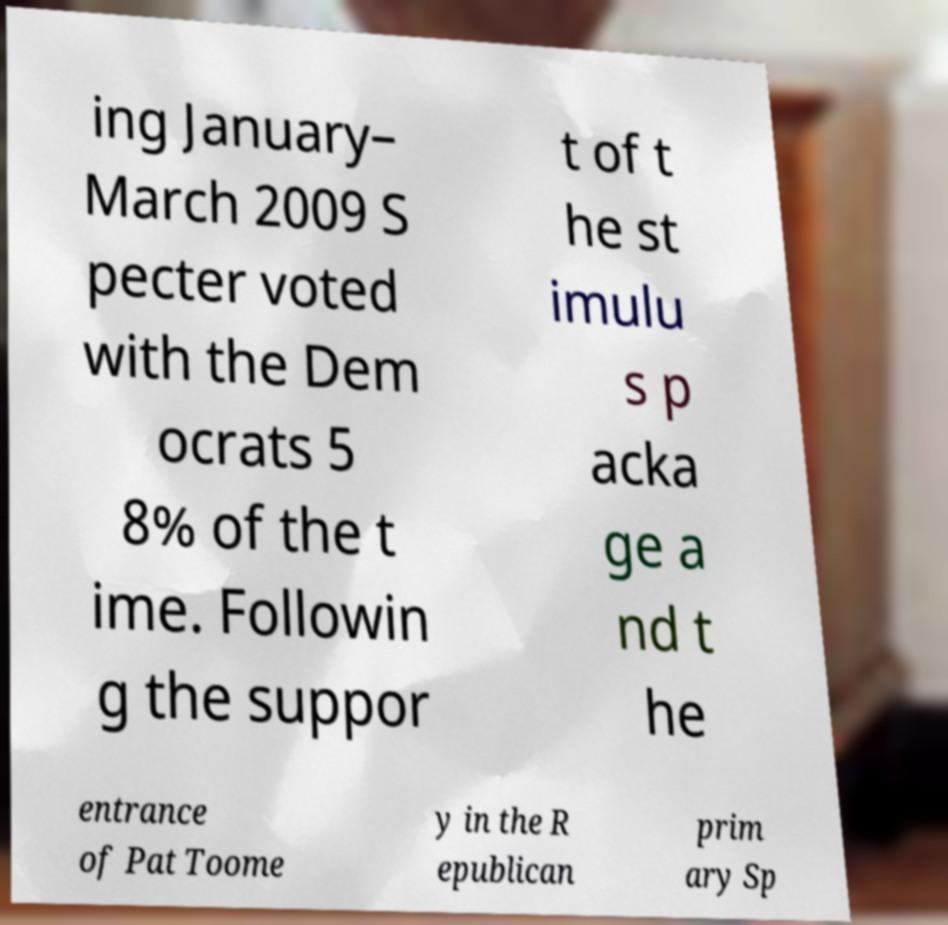Can you accurately transcribe the text from the provided image for me? ing January– March 2009 S pecter voted with the Dem ocrats 5 8% of the t ime. Followin g the suppor t of t he st imulu s p acka ge a nd t he entrance of Pat Toome y in the R epublican prim ary Sp 